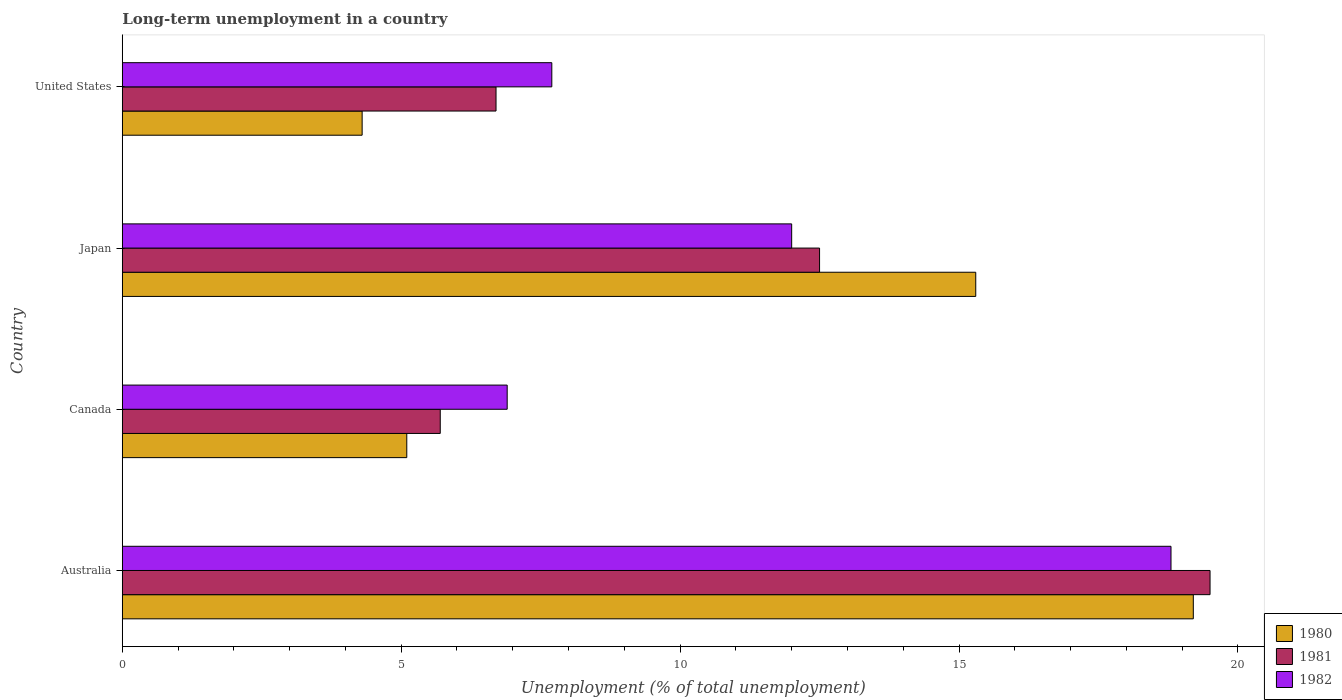How many different coloured bars are there?
Make the answer very short. 3. How many groups of bars are there?
Give a very brief answer. 4. Are the number of bars per tick equal to the number of legend labels?
Offer a very short reply. Yes. How many bars are there on the 3rd tick from the top?
Keep it short and to the point. 3. What is the label of the 1st group of bars from the top?
Keep it short and to the point. United States. What is the percentage of long-term unemployed population in 1980 in Canada?
Offer a terse response. 5.1. Across all countries, what is the maximum percentage of long-term unemployed population in 1982?
Provide a short and direct response. 18.8. Across all countries, what is the minimum percentage of long-term unemployed population in 1982?
Your response must be concise. 6.9. What is the total percentage of long-term unemployed population in 1980 in the graph?
Ensure brevity in your answer.  43.9. What is the difference between the percentage of long-term unemployed population in 1980 in Australia and that in United States?
Your answer should be very brief. 14.9. What is the difference between the percentage of long-term unemployed population in 1980 in United States and the percentage of long-term unemployed population in 1981 in Australia?
Your answer should be very brief. -15.2. What is the average percentage of long-term unemployed population in 1981 per country?
Give a very brief answer. 11.1. What is the difference between the percentage of long-term unemployed population in 1981 and percentage of long-term unemployed population in 1982 in Japan?
Offer a very short reply. 0.5. In how many countries, is the percentage of long-term unemployed population in 1982 greater than 2 %?
Offer a very short reply. 4. What is the ratio of the percentage of long-term unemployed population in 1982 in Australia to that in Canada?
Your answer should be compact. 2.72. Is the difference between the percentage of long-term unemployed population in 1981 in Australia and Japan greater than the difference between the percentage of long-term unemployed population in 1982 in Australia and Japan?
Provide a short and direct response. Yes. What is the difference between the highest and the second highest percentage of long-term unemployed population in 1981?
Provide a short and direct response. 7. What is the difference between the highest and the lowest percentage of long-term unemployed population in 1981?
Keep it short and to the point. 13.8. In how many countries, is the percentage of long-term unemployed population in 1980 greater than the average percentage of long-term unemployed population in 1980 taken over all countries?
Provide a succinct answer. 2. What does the 2nd bar from the top in United States represents?
Provide a succinct answer. 1981. Are all the bars in the graph horizontal?
Your response must be concise. Yes. How many countries are there in the graph?
Ensure brevity in your answer.  4. Does the graph contain any zero values?
Provide a succinct answer. No. Does the graph contain grids?
Provide a short and direct response. No. Where does the legend appear in the graph?
Your answer should be compact. Bottom right. How many legend labels are there?
Offer a terse response. 3. What is the title of the graph?
Provide a short and direct response. Long-term unemployment in a country. Does "1960" appear as one of the legend labels in the graph?
Your answer should be very brief. No. What is the label or title of the X-axis?
Provide a short and direct response. Unemployment (% of total unemployment). What is the label or title of the Y-axis?
Your answer should be very brief. Country. What is the Unemployment (% of total unemployment) of 1980 in Australia?
Offer a very short reply. 19.2. What is the Unemployment (% of total unemployment) in 1981 in Australia?
Offer a very short reply. 19.5. What is the Unemployment (% of total unemployment) in 1982 in Australia?
Keep it short and to the point. 18.8. What is the Unemployment (% of total unemployment) of 1980 in Canada?
Your answer should be compact. 5.1. What is the Unemployment (% of total unemployment) in 1981 in Canada?
Offer a terse response. 5.7. What is the Unemployment (% of total unemployment) in 1982 in Canada?
Provide a short and direct response. 6.9. What is the Unemployment (% of total unemployment) in 1980 in Japan?
Your answer should be compact. 15.3. What is the Unemployment (% of total unemployment) of 1981 in Japan?
Your answer should be compact. 12.5. What is the Unemployment (% of total unemployment) of 1982 in Japan?
Your answer should be very brief. 12. What is the Unemployment (% of total unemployment) of 1980 in United States?
Provide a succinct answer. 4.3. What is the Unemployment (% of total unemployment) in 1981 in United States?
Keep it short and to the point. 6.7. What is the Unemployment (% of total unemployment) in 1982 in United States?
Your answer should be very brief. 7.7. Across all countries, what is the maximum Unemployment (% of total unemployment) in 1980?
Provide a succinct answer. 19.2. Across all countries, what is the maximum Unemployment (% of total unemployment) in 1981?
Make the answer very short. 19.5. Across all countries, what is the maximum Unemployment (% of total unemployment) of 1982?
Offer a very short reply. 18.8. Across all countries, what is the minimum Unemployment (% of total unemployment) in 1980?
Your response must be concise. 4.3. Across all countries, what is the minimum Unemployment (% of total unemployment) in 1981?
Give a very brief answer. 5.7. Across all countries, what is the minimum Unemployment (% of total unemployment) in 1982?
Make the answer very short. 6.9. What is the total Unemployment (% of total unemployment) of 1980 in the graph?
Your answer should be compact. 43.9. What is the total Unemployment (% of total unemployment) of 1981 in the graph?
Offer a terse response. 44.4. What is the total Unemployment (% of total unemployment) in 1982 in the graph?
Make the answer very short. 45.4. What is the difference between the Unemployment (% of total unemployment) of 1981 in Australia and that in Canada?
Make the answer very short. 13.8. What is the difference between the Unemployment (% of total unemployment) of 1980 in Australia and that in Japan?
Your answer should be compact. 3.9. What is the difference between the Unemployment (% of total unemployment) of 1981 in Australia and that in Japan?
Provide a short and direct response. 7. What is the difference between the Unemployment (% of total unemployment) in 1980 in Australia and that in United States?
Offer a very short reply. 14.9. What is the difference between the Unemployment (% of total unemployment) of 1982 in Australia and that in United States?
Offer a very short reply. 11.1. What is the difference between the Unemployment (% of total unemployment) of 1980 in Canada and that in Japan?
Offer a terse response. -10.2. What is the difference between the Unemployment (% of total unemployment) in 1982 in Canada and that in Japan?
Your answer should be very brief. -5.1. What is the difference between the Unemployment (% of total unemployment) of 1980 in Canada and that in United States?
Give a very brief answer. 0.8. What is the difference between the Unemployment (% of total unemployment) in 1982 in Canada and that in United States?
Your answer should be compact. -0.8. What is the difference between the Unemployment (% of total unemployment) in 1980 in Japan and that in United States?
Give a very brief answer. 11. What is the difference between the Unemployment (% of total unemployment) in 1980 in Australia and the Unemployment (% of total unemployment) in 1981 in Canada?
Offer a terse response. 13.5. What is the difference between the Unemployment (% of total unemployment) of 1981 in Australia and the Unemployment (% of total unemployment) of 1982 in Canada?
Provide a short and direct response. 12.6. What is the difference between the Unemployment (% of total unemployment) of 1980 in Australia and the Unemployment (% of total unemployment) of 1981 in Japan?
Provide a succinct answer. 6.7. What is the difference between the Unemployment (% of total unemployment) of 1980 in Australia and the Unemployment (% of total unemployment) of 1982 in Japan?
Provide a succinct answer. 7.2. What is the difference between the Unemployment (% of total unemployment) in 1981 in Australia and the Unemployment (% of total unemployment) in 1982 in Japan?
Offer a terse response. 7.5. What is the difference between the Unemployment (% of total unemployment) of 1980 in Australia and the Unemployment (% of total unemployment) of 1982 in United States?
Offer a terse response. 11.5. What is the difference between the Unemployment (% of total unemployment) in 1980 in Canada and the Unemployment (% of total unemployment) in 1982 in United States?
Your response must be concise. -2.6. What is the difference between the Unemployment (% of total unemployment) in 1980 in Japan and the Unemployment (% of total unemployment) in 1981 in United States?
Offer a very short reply. 8.6. What is the difference between the Unemployment (% of total unemployment) in 1980 in Japan and the Unemployment (% of total unemployment) in 1982 in United States?
Make the answer very short. 7.6. What is the difference between the Unemployment (% of total unemployment) in 1981 in Japan and the Unemployment (% of total unemployment) in 1982 in United States?
Make the answer very short. 4.8. What is the average Unemployment (% of total unemployment) in 1980 per country?
Give a very brief answer. 10.97. What is the average Unemployment (% of total unemployment) of 1982 per country?
Your answer should be very brief. 11.35. What is the difference between the Unemployment (% of total unemployment) of 1981 and Unemployment (% of total unemployment) of 1982 in Australia?
Make the answer very short. 0.7. What is the difference between the Unemployment (% of total unemployment) of 1980 and Unemployment (% of total unemployment) of 1981 in Canada?
Offer a very short reply. -0.6. What is the difference between the Unemployment (% of total unemployment) of 1980 and Unemployment (% of total unemployment) of 1982 in Canada?
Make the answer very short. -1.8. What is the difference between the Unemployment (% of total unemployment) of 1980 and Unemployment (% of total unemployment) of 1981 in Japan?
Your answer should be compact. 2.8. What is the difference between the Unemployment (% of total unemployment) in 1980 and Unemployment (% of total unemployment) in 1981 in United States?
Provide a succinct answer. -2.4. What is the difference between the Unemployment (% of total unemployment) in 1980 and Unemployment (% of total unemployment) in 1982 in United States?
Provide a short and direct response. -3.4. What is the ratio of the Unemployment (% of total unemployment) in 1980 in Australia to that in Canada?
Provide a succinct answer. 3.76. What is the ratio of the Unemployment (% of total unemployment) of 1981 in Australia to that in Canada?
Ensure brevity in your answer.  3.42. What is the ratio of the Unemployment (% of total unemployment) in 1982 in Australia to that in Canada?
Your response must be concise. 2.72. What is the ratio of the Unemployment (% of total unemployment) in 1980 in Australia to that in Japan?
Provide a succinct answer. 1.25. What is the ratio of the Unemployment (% of total unemployment) in 1981 in Australia to that in Japan?
Provide a succinct answer. 1.56. What is the ratio of the Unemployment (% of total unemployment) in 1982 in Australia to that in Japan?
Offer a very short reply. 1.57. What is the ratio of the Unemployment (% of total unemployment) of 1980 in Australia to that in United States?
Your response must be concise. 4.47. What is the ratio of the Unemployment (% of total unemployment) in 1981 in Australia to that in United States?
Your answer should be very brief. 2.91. What is the ratio of the Unemployment (% of total unemployment) in 1982 in Australia to that in United States?
Your response must be concise. 2.44. What is the ratio of the Unemployment (% of total unemployment) in 1980 in Canada to that in Japan?
Ensure brevity in your answer.  0.33. What is the ratio of the Unemployment (% of total unemployment) of 1981 in Canada to that in Japan?
Your answer should be very brief. 0.46. What is the ratio of the Unemployment (% of total unemployment) of 1982 in Canada to that in Japan?
Your response must be concise. 0.57. What is the ratio of the Unemployment (% of total unemployment) in 1980 in Canada to that in United States?
Provide a succinct answer. 1.19. What is the ratio of the Unemployment (% of total unemployment) in 1981 in Canada to that in United States?
Your response must be concise. 0.85. What is the ratio of the Unemployment (% of total unemployment) of 1982 in Canada to that in United States?
Provide a succinct answer. 0.9. What is the ratio of the Unemployment (% of total unemployment) of 1980 in Japan to that in United States?
Provide a short and direct response. 3.56. What is the ratio of the Unemployment (% of total unemployment) of 1981 in Japan to that in United States?
Offer a very short reply. 1.87. What is the ratio of the Unemployment (% of total unemployment) of 1982 in Japan to that in United States?
Ensure brevity in your answer.  1.56. What is the difference between the highest and the second highest Unemployment (% of total unemployment) of 1980?
Your response must be concise. 3.9. 